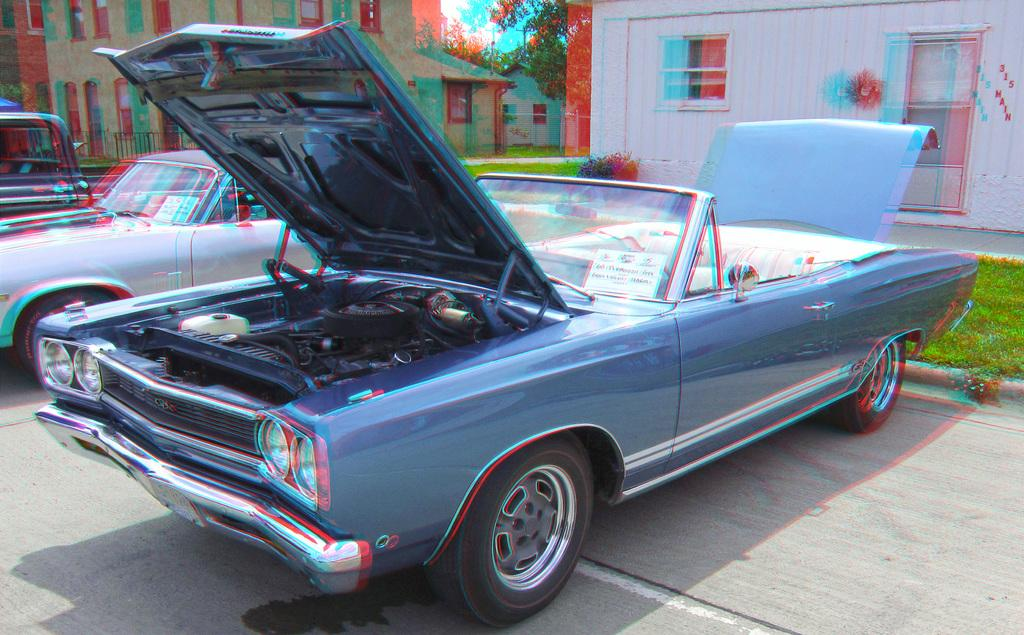What type of vehicles can be seen in the image? There are cars in the image. What else is present in the image besides cars? There are posters with text, houses, windows, trees, and grass visible in the image. What is the condition of the sky in the image? The sky is clouded in the image. How many pizzas are being served by the squirrel in the image? There is no squirrel or pizzas present in the image. 